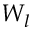Convert formula to latex. <formula><loc_0><loc_0><loc_500><loc_500>W _ { l }</formula> 